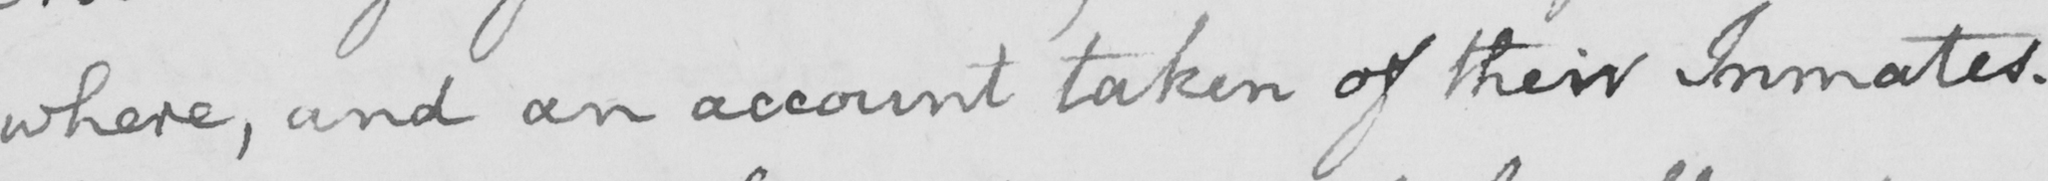Transcribe the text shown in this historical manuscript line. -where , and an account taken of their Inmates . 